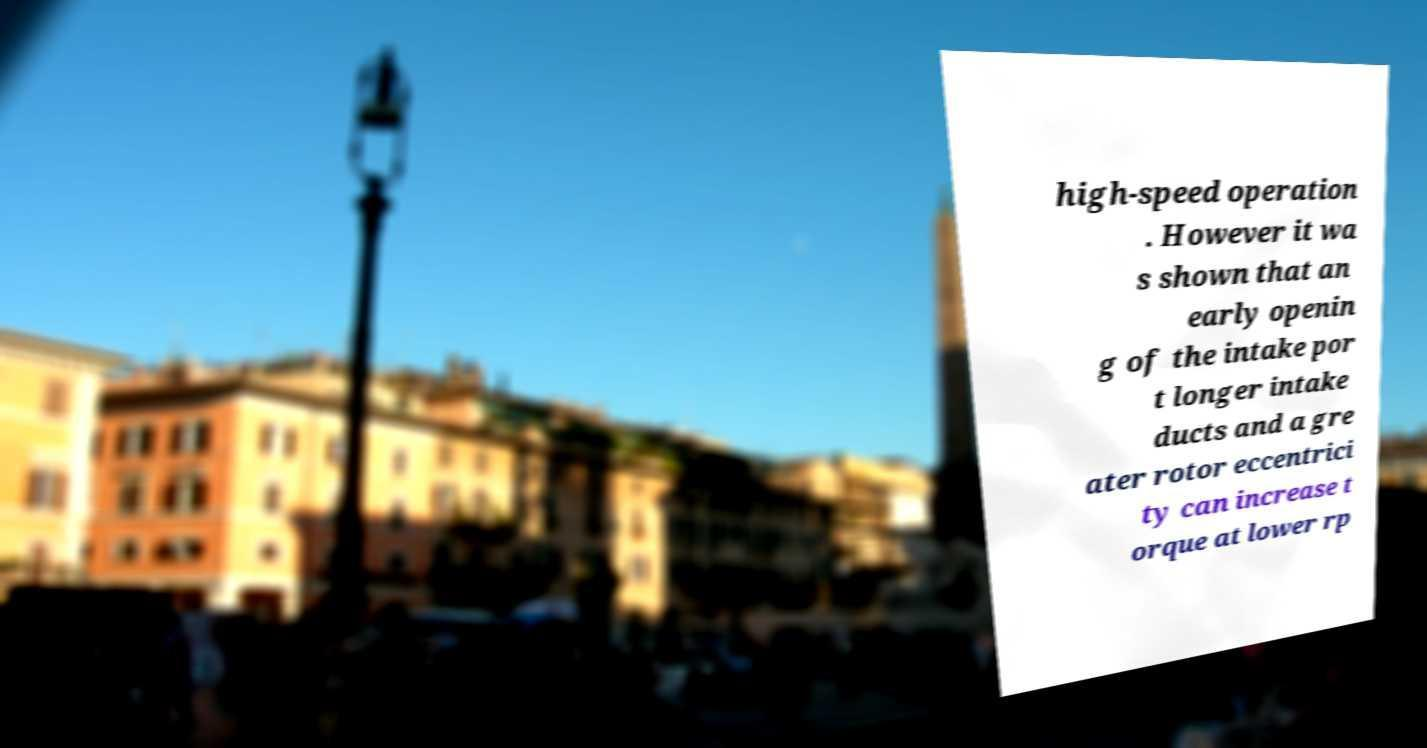Can you accurately transcribe the text from the provided image for me? high-speed operation . However it wa s shown that an early openin g of the intake por t longer intake ducts and a gre ater rotor eccentrici ty can increase t orque at lower rp 